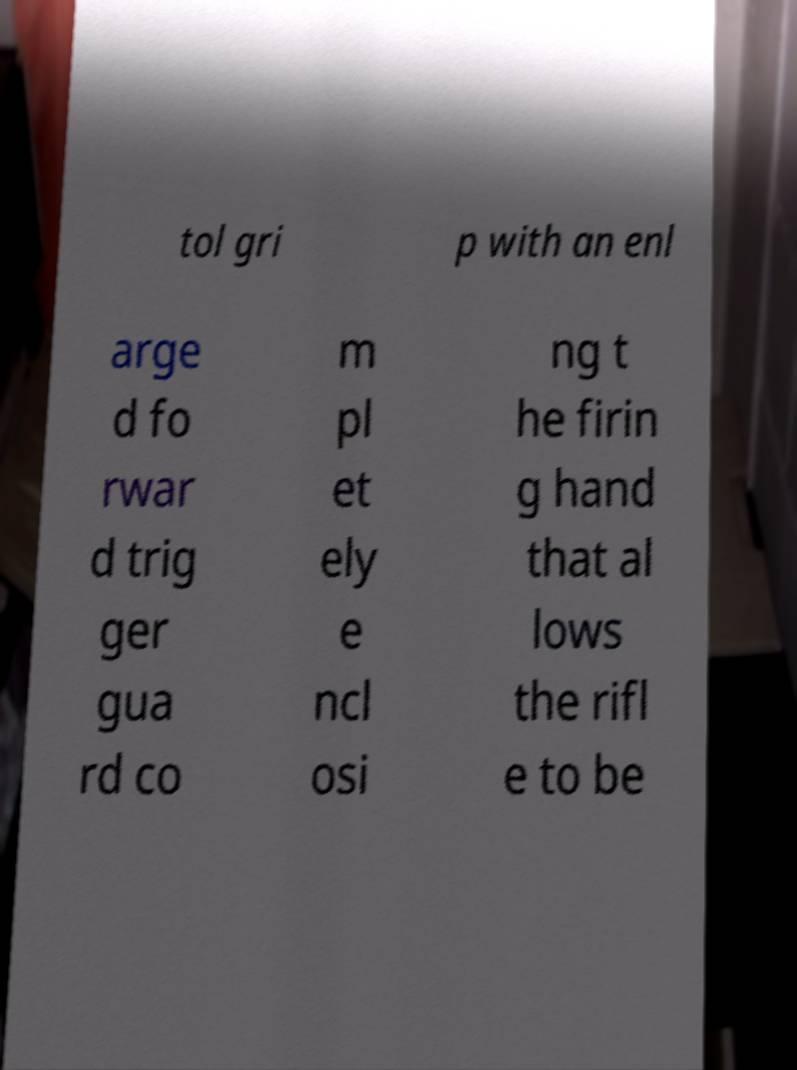Could you extract and type out the text from this image? tol gri p with an enl arge d fo rwar d trig ger gua rd co m pl et ely e ncl osi ng t he firin g hand that al lows the rifl e to be 